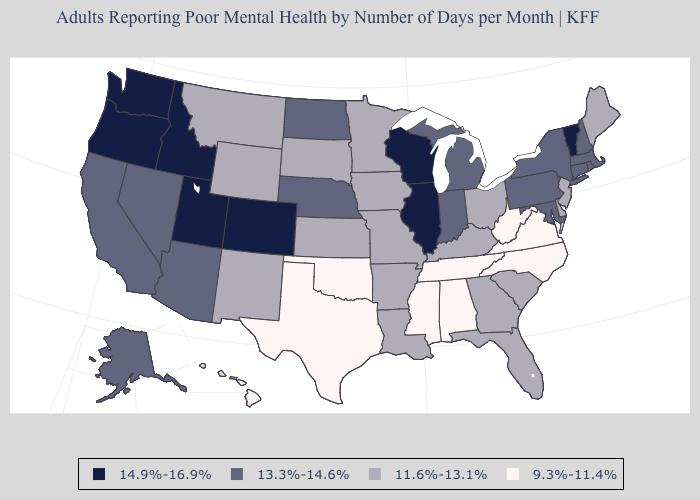What is the highest value in the MidWest ?
Give a very brief answer. 14.9%-16.9%. What is the value of Texas?
Give a very brief answer. 9.3%-11.4%. What is the value of Nebraska?
Be succinct. 13.3%-14.6%. What is the highest value in states that border Louisiana?
Short answer required. 11.6%-13.1%. What is the value of California?
Answer briefly. 13.3%-14.6%. Is the legend a continuous bar?
Concise answer only. No. Does Alabama have the lowest value in the USA?
Answer briefly. Yes. Does Ohio have a higher value than Maryland?
Be succinct. No. What is the value of Virginia?
Give a very brief answer. 9.3%-11.4%. Which states have the lowest value in the Northeast?
Give a very brief answer. Maine, New Jersey. What is the highest value in the Northeast ?
Write a very short answer. 14.9%-16.9%. What is the highest value in the South ?
Keep it brief. 13.3%-14.6%. Name the states that have a value in the range 13.3%-14.6%?
Write a very short answer. Alaska, Arizona, California, Connecticut, Indiana, Maryland, Massachusetts, Michigan, Nebraska, Nevada, New Hampshire, New York, North Dakota, Pennsylvania, Rhode Island. Does Washington have the highest value in the USA?
Keep it brief. Yes. Name the states that have a value in the range 9.3%-11.4%?
Concise answer only. Alabama, Hawaii, Mississippi, North Carolina, Oklahoma, Tennessee, Texas, Virginia, West Virginia. 